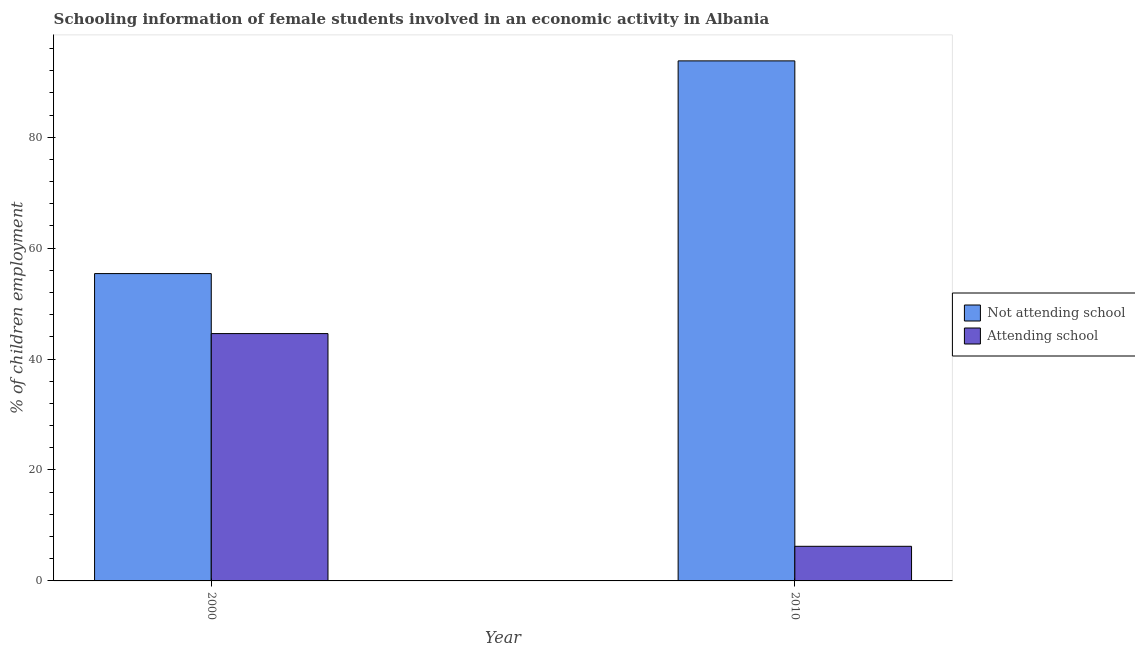How many different coloured bars are there?
Give a very brief answer. 2. Are the number of bars per tick equal to the number of legend labels?
Offer a terse response. Yes. How many bars are there on the 2nd tick from the left?
Your response must be concise. 2. In how many cases, is the number of bars for a given year not equal to the number of legend labels?
Keep it short and to the point. 0. What is the percentage of employed females who are not attending school in 2010?
Make the answer very short. 93.76. Across all years, what is the maximum percentage of employed females who are attending school?
Offer a very short reply. 44.59. Across all years, what is the minimum percentage of employed females who are attending school?
Your response must be concise. 6.24. In which year was the percentage of employed females who are attending school minimum?
Give a very brief answer. 2010. What is the total percentage of employed females who are not attending school in the graph?
Keep it short and to the point. 149.17. What is the difference between the percentage of employed females who are not attending school in 2000 and that in 2010?
Your answer should be compact. -38.35. What is the difference between the percentage of employed females who are attending school in 2010 and the percentage of employed females who are not attending school in 2000?
Keep it short and to the point. -38.35. What is the average percentage of employed females who are not attending school per year?
Your answer should be compact. 74.58. What is the ratio of the percentage of employed females who are not attending school in 2000 to that in 2010?
Offer a very short reply. 0.59. Is the percentage of employed females who are not attending school in 2000 less than that in 2010?
Your answer should be very brief. Yes. What does the 2nd bar from the left in 2000 represents?
Your answer should be compact. Attending school. What does the 1st bar from the right in 2000 represents?
Ensure brevity in your answer.  Attending school. How many bars are there?
Keep it short and to the point. 4. How many years are there in the graph?
Keep it short and to the point. 2. What is the difference between two consecutive major ticks on the Y-axis?
Ensure brevity in your answer.  20. Are the values on the major ticks of Y-axis written in scientific E-notation?
Your answer should be very brief. No. Does the graph contain grids?
Offer a very short reply. No. Where does the legend appear in the graph?
Your answer should be very brief. Center right. How many legend labels are there?
Keep it short and to the point. 2. What is the title of the graph?
Provide a short and direct response. Schooling information of female students involved in an economic activity in Albania. What is the label or title of the Y-axis?
Offer a very short reply. % of children employment. What is the % of children employment of Not attending school in 2000?
Your answer should be very brief. 55.41. What is the % of children employment in Attending school in 2000?
Your answer should be compact. 44.59. What is the % of children employment of Not attending school in 2010?
Give a very brief answer. 93.76. What is the % of children employment in Attending school in 2010?
Your answer should be very brief. 6.24. Across all years, what is the maximum % of children employment in Not attending school?
Offer a very short reply. 93.76. Across all years, what is the maximum % of children employment of Attending school?
Give a very brief answer. 44.59. Across all years, what is the minimum % of children employment in Not attending school?
Provide a short and direct response. 55.41. Across all years, what is the minimum % of children employment of Attending school?
Your answer should be very brief. 6.24. What is the total % of children employment of Not attending school in the graph?
Keep it short and to the point. 149.17. What is the total % of children employment of Attending school in the graph?
Keep it short and to the point. 50.83. What is the difference between the % of children employment of Not attending school in 2000 and that in 2010?
Provide a short and direct response. -38.35. What is the difference between the % of children employment of Attending school in 2000 and that in 2010?
Ensure brevity in your answer.  38.35. What is the difference between the % of children employment in Not attending school in 2000 and the % of children employment in Attending school in 2010?
Your answer should be very brief. 49.17. What is the average % of children employment in Not attending school per year?
Your response must be concise. 74.58. What is the average % of children employment in Attending school per year?
Make the answer very short. 25.42. In the year 2000, what is the difference between the % of children employment in Not attending school and % of children employment in Attending school?
Offer a very short reply. 10.81. In the year 2010, what is the difference between the % of children employment in Not attending school and % of children employment in Attending school?
Keep it short and to the point. 87.52. What is the ratio of the % of children employment in Not attending school in 2000 to that in 2010?
Offer a very short reply. 0.59. What is the ratio of the % of children employment of Attending school in 2000 to that in 2010?
Make the answer very short. 7.14. What is the difference between the highest and the second highest % of children employment of Not attending school?
Give a very brief answer. 38.35. What is the difference between the highest and the second highest % of children employment in Attending school?
Provide a short and direct response. 38.35. What is the difference between the highest and the lowest % of children employment in Not attending school?
Make the answer very short. 38.35. What is the difference between the highest and the lowest % of children employment of Attending school?
Offer a very short reply. 38.35. 